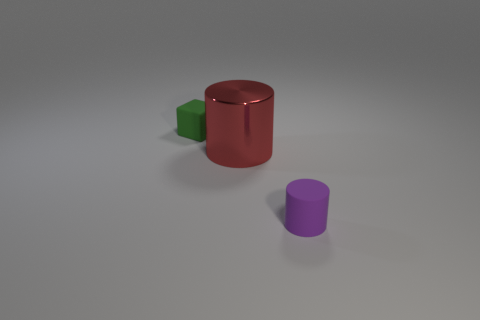There is a object that is the same size as the green matte block; what material is it?
Provide a succinct answer. Rubber. Are there any other large blue cubes made of the same material as the block?
Your answer should be very brief. No. Is the number of matte cubes in front of the big metal object less than the number of large red shiny objects?
Your answer should be very brief. Yes. The cylinder on the left side of the small object that is on the right side of the tiny green thing is made of what material?
Offer a very short reply. Metal. There is a thing that is both behind the matte cylinder and on the right side of the green matte thing; what is its shape?
Provide a short and direct response. Cylinder. How many other things are there of the same color as the large metal cylinder?
Your answer should be very brief. 0. How many things are tiny rubber objects that are behind the red metal cylinder or gray cylinders?
Your response must be concise. 1. Does the tiny rubber cube have the same color as the rubber object that is in front of the matte block?
Ensure brevity in your answer.  No. Is there anything else that is the same size as the red thing?
Give a very brief answer. No. There is a green rubber cube that is on the left side of the tiny thing that is to the right of the red cylinder; how big is it?
Provide a succinct answer. Small. 